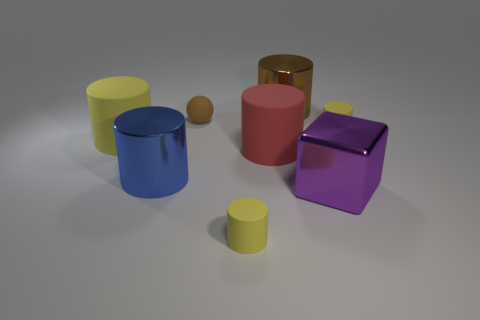Is the color of the metal block the same as the large rubber object that is to the left of the blue cylinder? no 